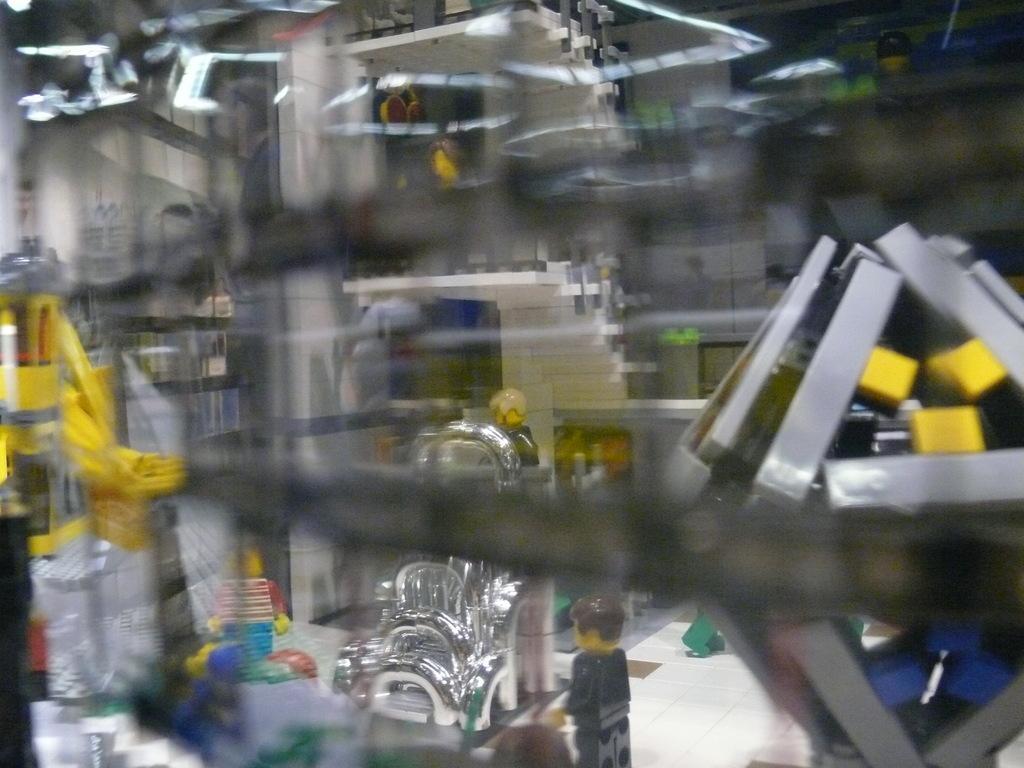Please provide a concise description of this image. In this picture I can see a blurry image and I can see few miniatures and machines and few items on the floor. 